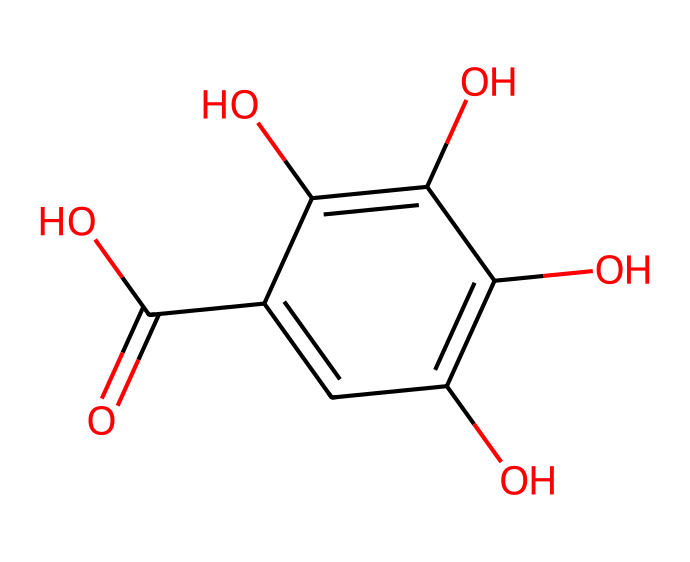How many hydroxyl groups are present in gallic acid? By analyzing the structure, we look for -OH groups connected to the carbon atoms. In the provided SMILES, we can identify three distinct -OH (hydroxyl) groups on the benzene ring.
Answer: three What is the molecular formula of gallic acid? The molecular structure indicates there are six carbon atoms, six hydrogen atoms, and five oxygen atoms. Therefore, the molecular formula can be derived as C7H6O5.
Answer: C7H6O5 Which functional group contributes to the antioxidant properties of gallic acid? The presence of catechol-like hydroxyl groups on the aromatic structure is crucial, as these groups can donate electrons and scavenge free radicals, contributing to antioxidant activity.
Answer: hydroxyl groups How many rings does gallic acid have in its structure? Observing the structure, we note a single aromatic ring that contains multiple substituents, therefore indicating that it has one ring.
Answer: one What type of organic compound is gallic acid classified as? Given that gallic acid contains multiple hydroxyl groups attached to a benzene ring and exhibits acidic properties, it can be classified as a phenolic acid.
Answer: phenolic acid Which part of the structure indicates it is a carboxylic acid? The presence of the -COOH group in the structure signifies that it belongs to the carboxylic acid family, which is demonstrated by the carbon atom double-bonded to one oxygen and single-bonded to a hydroxyl group.
Answer: -COOH group 